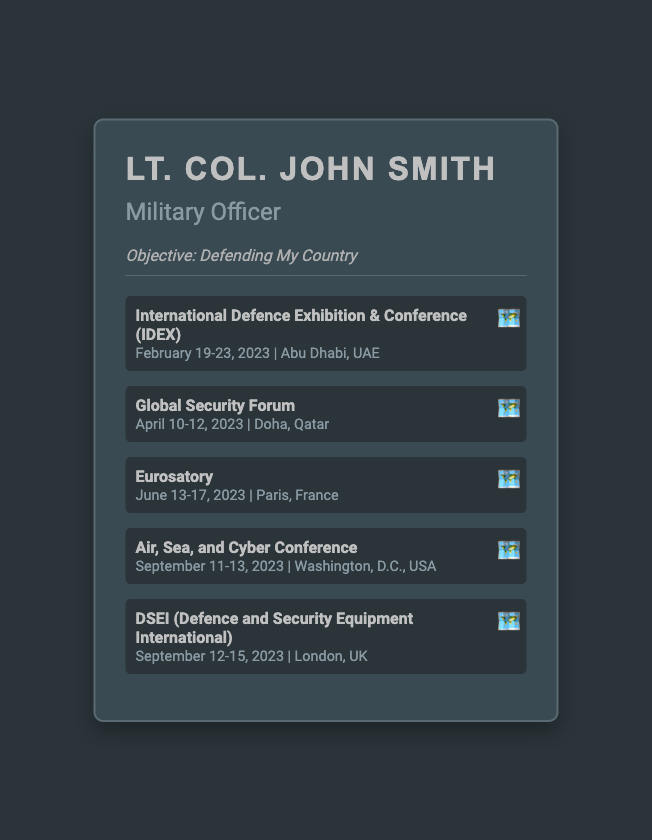what is the name of the officer? The officer's name is presented prominently at the top of the document.
Answer: Lt. Col. John Smith what is the objective of the officer? The objective section clearly states the mission of the officer.
Answer: Defending My Country which event is scheduled in Abu Dhabi, UAE? The document lists an event and its location in the upcoming events section.
Answer: International Defence Exhibition & Conference (IDEX) when does the Global Security Forum take place? The document specifies the date range for this event in the details.
Answer: April 10-12, 2023 how many events are listed in total? By counting the events within the document, we can determine the total number.
Answer: Five which city will the Air, Sea, and Cyber Conference be held in? The location for this specific event is stated in the details.
Answer: Washington, D.C., USA what is the date range for DSEI? The document provides the specific dates for this event.
Answer: September 12-15, 2023 which event takes place in London, UK? The location mentioned in the document helps identify the associated event.
Answer: DSEI (Defence and Security Equipment International) what is the date of Eurosatory? The precise dates for this event are stated in the event details.
Answer: June 13-17, 2023 